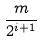<formula> <loc_0><loc_0><loc_500><loc_500>\frac { m } { 2 ^ { i + 1 } }</formula> 